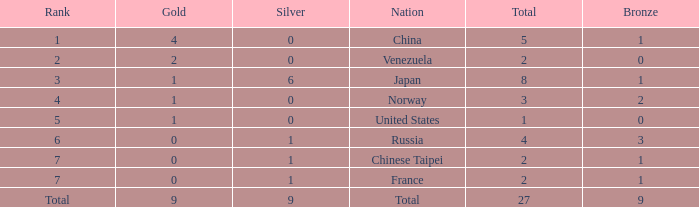What is the Nation when there is a total less than 27, gold is less than 1, and bronze is more than 1? Russia. 